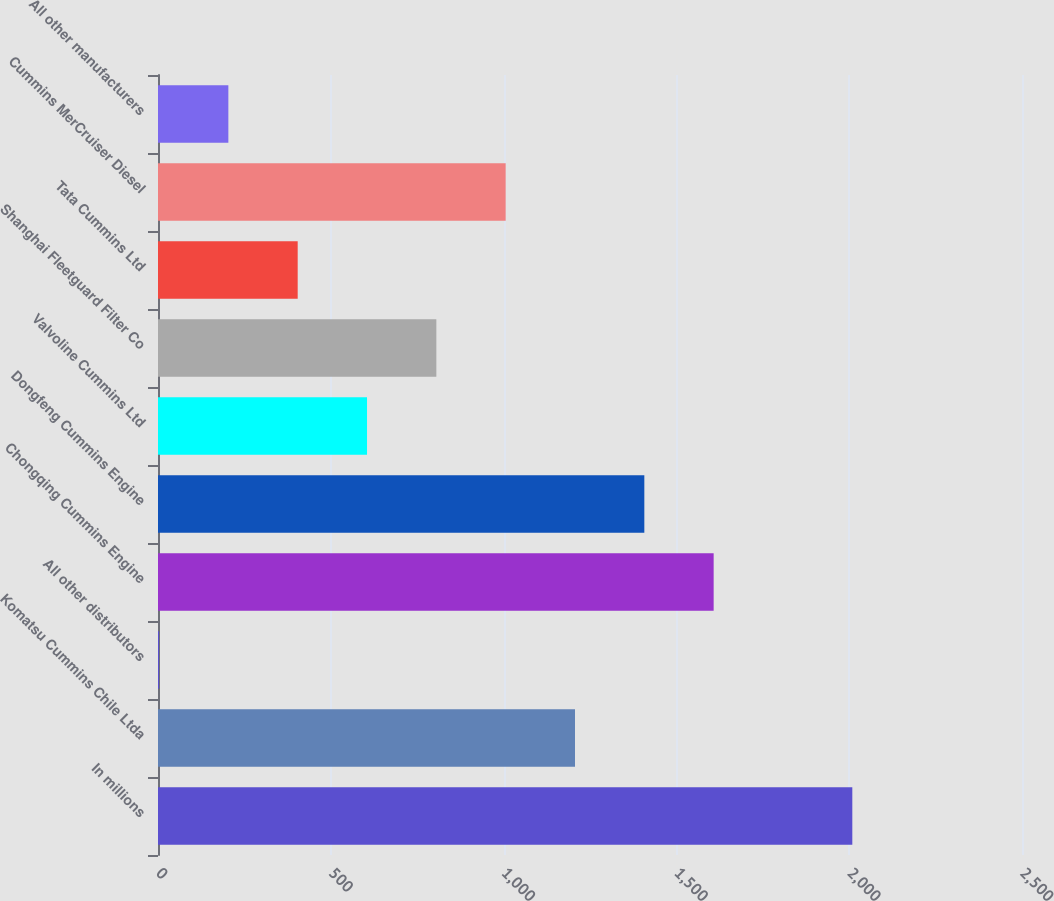Convert chart to OTSL. <chart><loc_0><loc_0><loc_500><loc_500><bar_chart><fcel>In millions<fcel>Komatsu Cummins Chile Ltda<fcel>All other distributors<fcel>Chongqing Cummins Engine<fcel>Dongfeng Cummins Engine<fcel>Valvoline Cummins Ltd<fcel>Shanghai Fleetguard Filter Co<fcel>Tata Cummins Ltd<fcel>Cummins MerCruiser Diesel<fcel>All other manufacturers<nl><fcel>2009<fcel>1206.6<fcel>3<fcel>1607.8<fcel>1407.2<fcel>604.8<fcel>805.4<fcel>404.2<fcel>1006<fcel>203.6<nl></chart> 